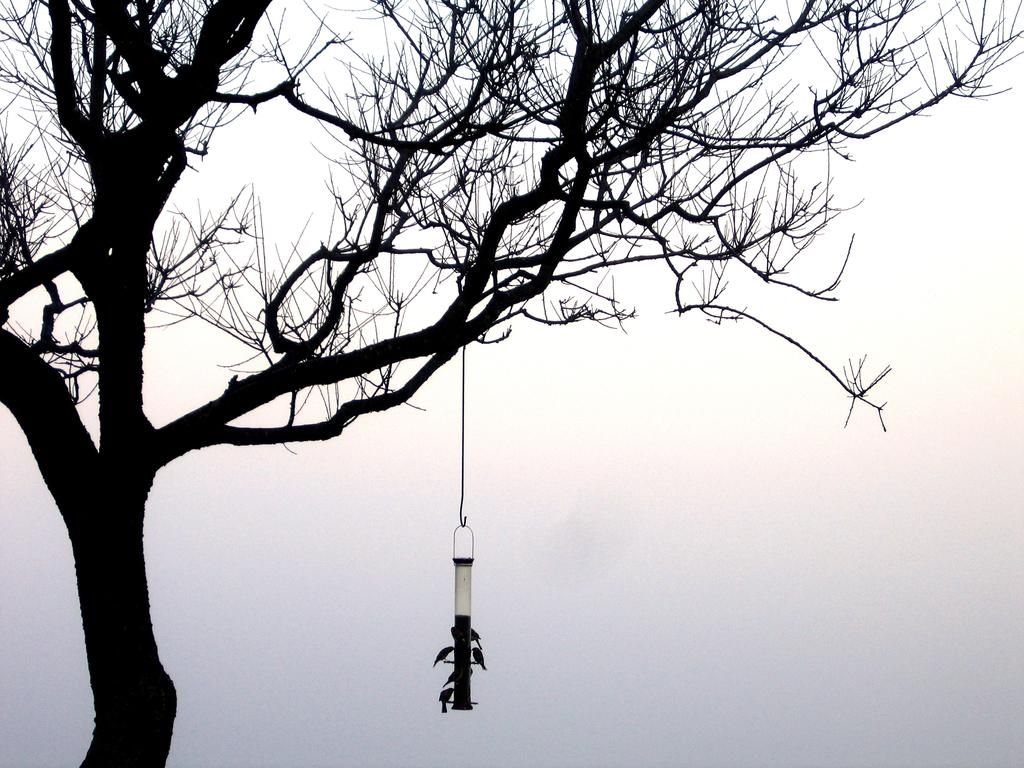What is hanging from the tree branch in the image? There is a bird feeder hanging from a tree branch in the image. What is the purpose of the bird feeder? The bird feeder is meant to provide food for birds. Can you describe the birds in the image? Yes, there are birds in the image. What can be seen in the background of the image? The sky is visible in the background of the image. What type of country music is playing in the background of the image? There is no music or reference to a country in the image; it features a bird feeder hanging from a tree branch with birds nearby. 